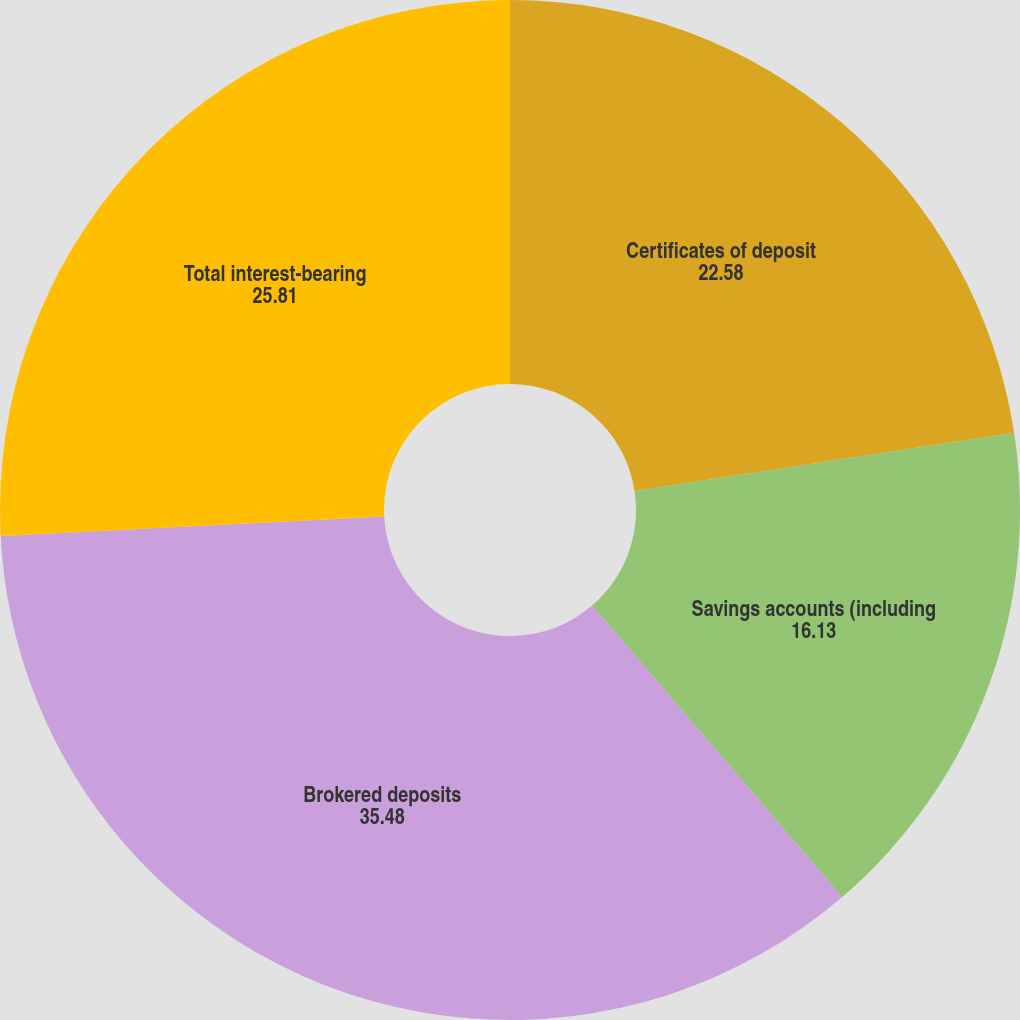<chart> <loc_0><loc_0><loc_500><loc_500><pie_chart><fcel>Certificates of deposit<fcel>Savings accounts (including<fcel>Brokered deposits<fcel>Total interest-bearing<nl><fcel>22.58%<fcel>16.13%<fcel>35.48%<fcel>25.81%<nl></chart> 